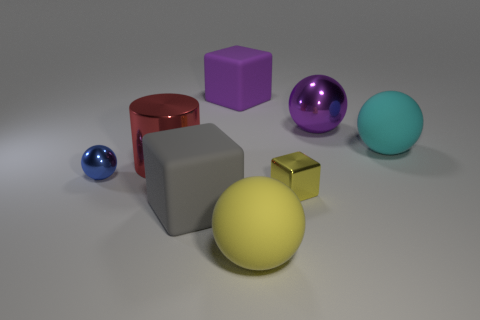How does the lighting affect the appearance of the objects in the image? The lighting in the image is soft and seems to come from above, casting gentle shadows beneath each object, which helps to enhance the three-dimensional aspect of each form. The reflective objects gleam and show specular highlights that accentuate their curvature and shape, while the matte objects exhibit a more even and diffused reflection, which softens their appearance and makes their colors seem more consistent across their surfaces. Are shadows important for perceiving depth? Absolutely, shadows are crucial visual cues for perceiving depth and spatial relationships in a two-dimensional image. They provide information about the light source's direction, the shape of the objects casting them, and the distances between various elements within the scene. 